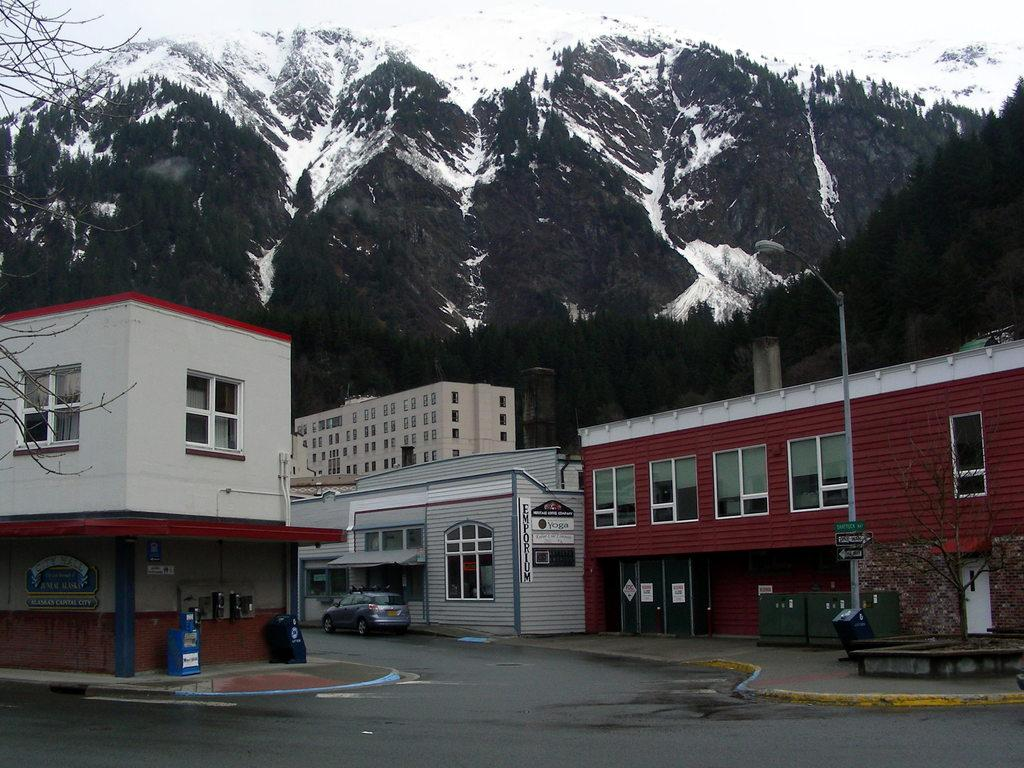What is the main feature of the image? There is a road in the image. What can be seen on both sides of the road? There are buildings on either side of the road. What is visible in the background of the image? There is a mountain in the background of the image. What is the condition of the mountain? The mountain is covered with snow. What type of sound can be heard coming from the wilderness in the image? There is no wilderness present in the image, and therefore no sound can be heard coming from it. Can you see a rat in the image? There is no rat present in the image. 